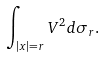<formula> <loc_0><loc_0><loc_500><loc_500>\int _ { | x | = r } V ^ { 2 } d \sigma _ { r } .</formula> 